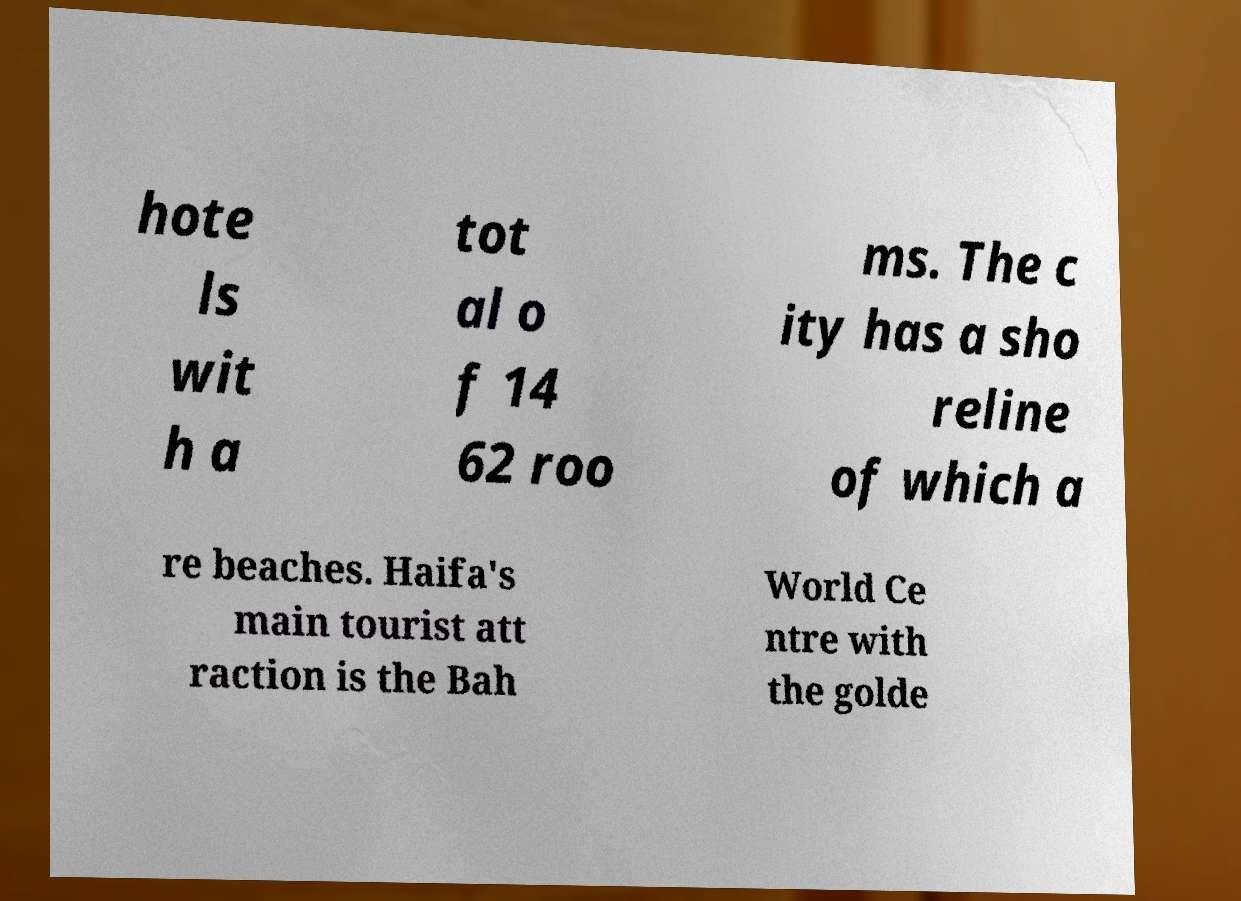Can you accurately transcribe the text from the provided image for me? hote ls wit h a tot al o f 14 62 roo ms. The c ity has a sho reline of which a re beaches. Haifa's main tourist att raction is the Bah World Ce ntre with the golde 